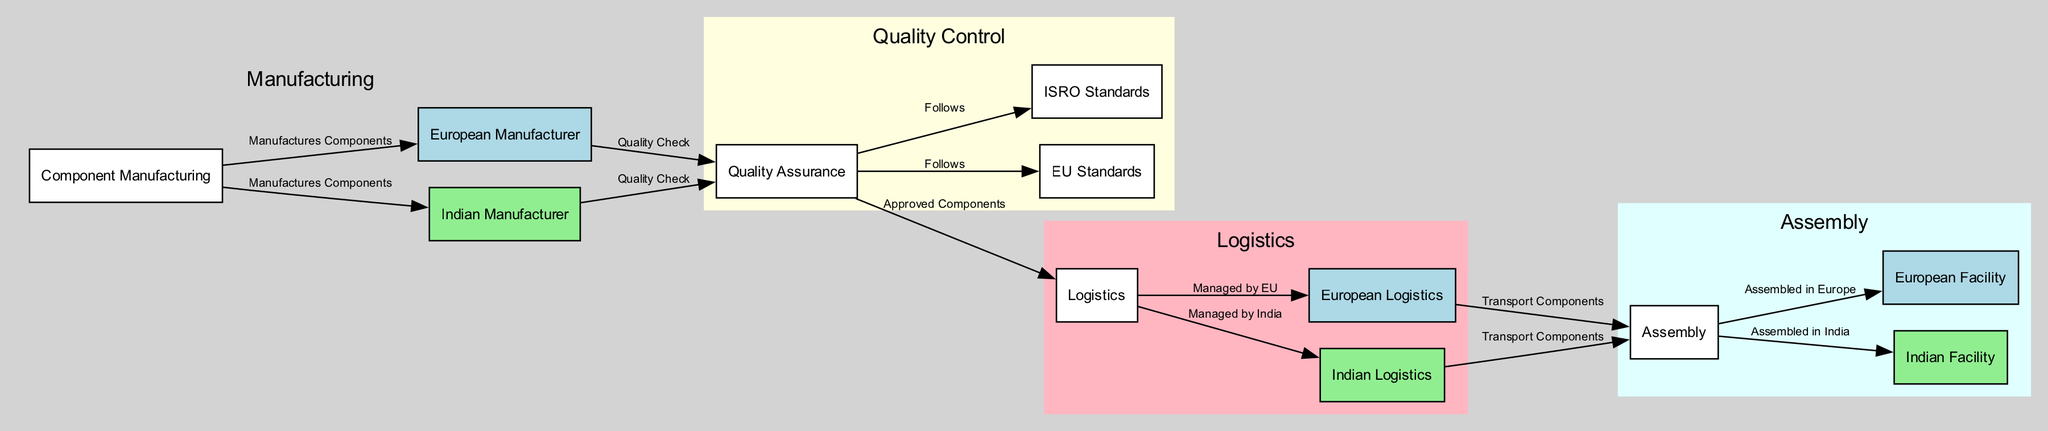What is the total number of nodes in the diagram? The diagram consists of a total of 12 nodes that represent the different stages and entities in the supply chain for spacecraft components.
Answer: 12 Which component manufactures parts in Europe? The node labeled "European Manufacturer" shows the entity responsible for manufacturing components in Europe.
Answer: European Manufacturer Which standards does Quality Assurance follow for European components? The label "Follows" points from Quality Assurance to the node EU Standards, indicating that it adheres to these regulations for European components.
Answer: EU Standards What is the primary difference in logistics management between European and Indian manufacturers? The "Logistics" node has edges indicating that it has separate paths for European Logistics and Indian Logistics, signifying that each follows local regulations for managing logistics.
Answer: Managed by EU and Managed by India Which node indicates where spacecraft components are assembled in India? The node "Indian Facility" specifically represents the location for assembling spacecraft components in India.
Answer: Indian Facility What is the purpose of the "Quality Assurance" node? The "Quality Assurance" node is critical in the diagram, serving as a checkpoint to ensure that all manufactured components meet necessary standards before logistics and assembly.
Answer: Ensures quality standards How many edges are there in total connecting the nodes? Counting all the connections between the nodes in the diagram reveals that there are 14 edges that represent the relationships and flow between various stages and entities in the supply chain.
Answer: 14 Which subgraph contains the Indian manufacturing components? The cluster labeled "Manufacturing" encompasses both the "Indian Manufacturer" and other nodes directly related to manufacturing, indicating where the Indian manufacturing components are discussed.
Answer: Manufacturing What do the edges from "Logistics" to "European Logistics" and "Indian Logistics" signify? The edges from "Logistics" to these two nodes signify that the main logistics node directs the flow of components either according to European regulations or Indian regulations based on the source of manufacture.
Answer: Transport Components 